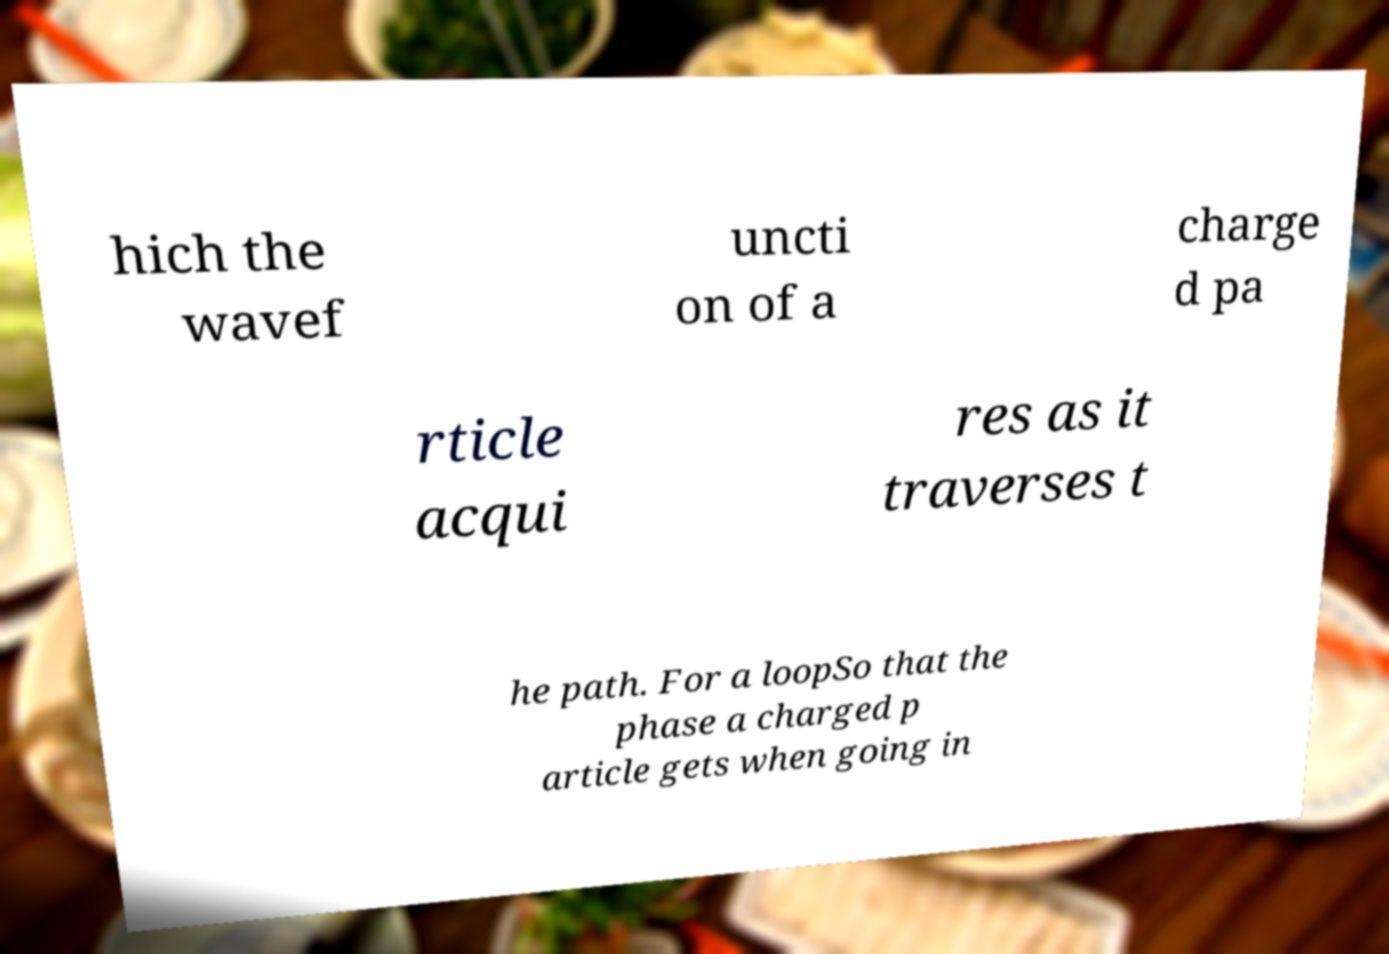For documentation purposes, I need the text within this image transcribed. Could you provide that? hich the wavef uncti on of a charge d pa rticle acqui res as it traverses t he path. For a loopSo that the phase a charged p article gets when going in 